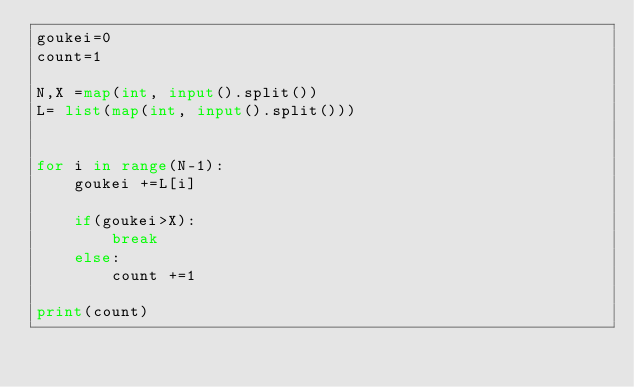<code> <loc_0><loc_0><loc_500><loc_500><_Python_>goukei=0 
count=1

N,X =map(int, input().split())
L= list(map(int, input().split()))
    

for i in range(N-1):
    goukei +=L[i]
    
    if(goukei>X):
        break
    else:
        count +=1
        
print(count)</code> 